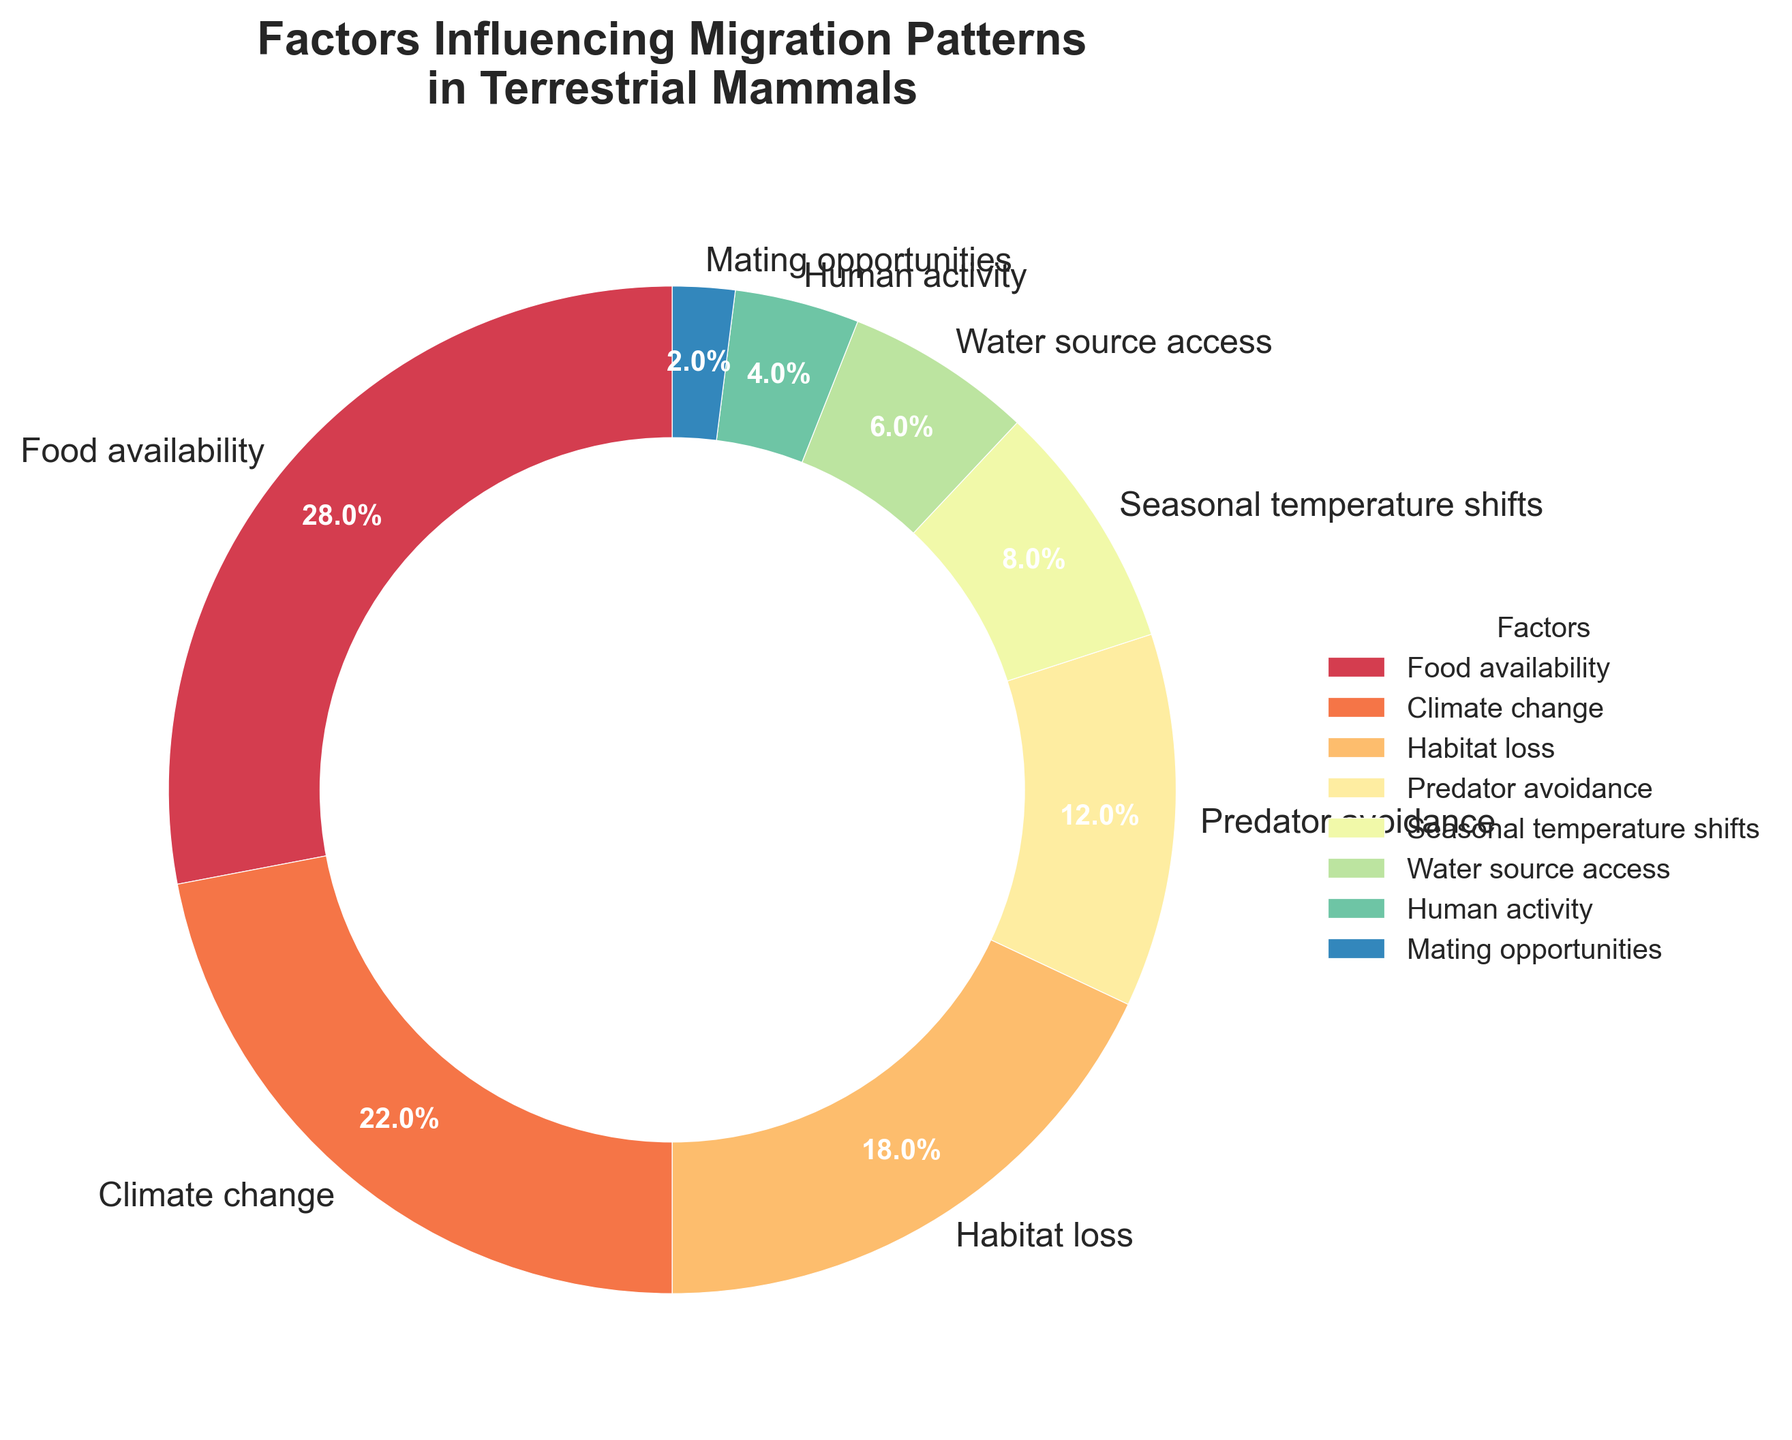What factor has the highest percentage influence on migration patterns? The factor with the highest percentage can be identified by looking at the section of the pie chart that covers the largest area. This corresponds to "Food availability," which is 28%.
Answer: Food availability Which two factors together account for nearly half of the influence on migration patterns? To determine which two factors together account for nearly half, we sum the percentages of the highest factors until we reach close to 50%. First, "Food availability" is 28%, and adding "Climate change" at 22%, we get 50%.
Answer: Food availability and Climate change How much more significant is habitat loss compared to human activity in influencing migration patterns? To find the difference between "Habitat loss" and "Human activity," subtract the percentage of "Human activity" from "Habitat loss" (18% - 4%).
Answer: 14% What is the combined influence of water source access and mating opportunities on migration patterns? Adding the percentages for "Water source access" (6%) and "Mating opportunities" (2%), we get a combined value (6% + 2%).
Answer: 8% Which factor is the least significant in influencing migration patterns? The smallest wedge in the pie chart represents the factor with the lowest percentage, which is "Mating opportunities" at 2%.
Answer: Mating opportunities Is the influence of predator avoidance higher or lower than that of seasonal temperature shifts? By comparing the percentages directly, "Predator avoidance" is 12%, and "Seasonal temperature shifts" is 8%. Predator avoidance is higher.
Answer: Higher What visual clues help you identify the factor contributing to exactly one-fourth of the influence? A quarter of a pie chart is visually 25%, and the wedge that is closest to this is "Food availability" at 28%. The size and color of the wedge provide visual clues.
Answer: Food availability Among the top three factors, which one has the smallest influence and by how much? The top three factors are "Food availability" (28%), "Climate change" (22%), and "Habitat loss" (18%). The smallest among them is "Habitat loss" at 18%. To find how much smaller it is compared to the next factor ("Climate change" at 22%), we subtract 18% from 22% (22% - 18%).
Answer: Habitat loss by 4% Which factor has exactly double the influence of human activity? The factor that has exactly double the influence of "Human activity" (4%) is "Water source access" (6%), since 6% is not double of 4%, but "Predator avoidance" is at 12%, which is double of 6%. Therefore, it should be the next factor which is double.
Answer: Predator avoidance 